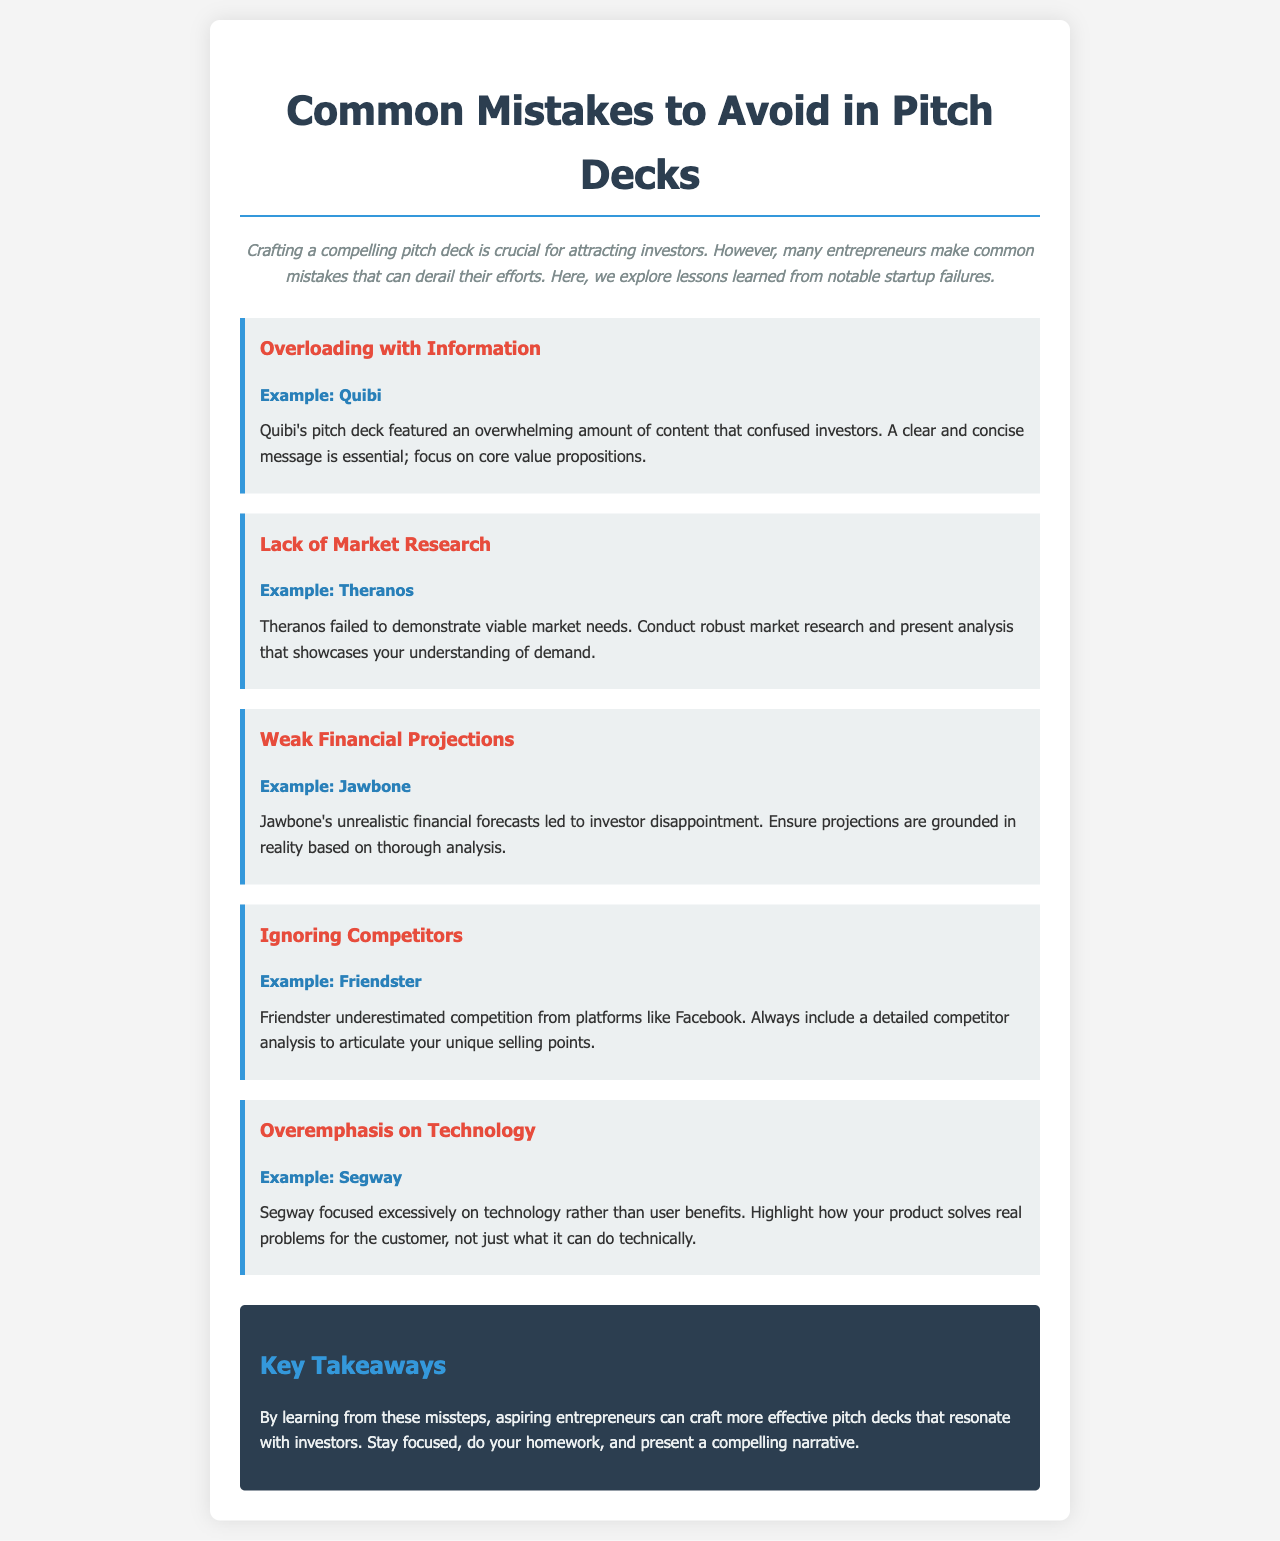what is the title of the document? The title of the document, which captures the main topic, is found at the top of the newsletter.
Answer: Common Mistakes to Avoid in Pitch Decks what example does the document provide for overloading with information? The document mentions a specific startup example to illustrate the mistake of overloading with information.
Answer: Quibi which startup is associated with a lack of market research? The document identifies a startup that failed due to insufficient market analysis.
Answer: Theranos what is highlighted as a common mistake in pitch decks? The document lists several mistakes; picking one mistake shows common pitfalls that entrepreneurs face.
Answer: Weak Financial Projections how many mistakes are discussed in the document? A count of the mistakes addressed throughout the newsletter reveals how many are presented.
Answer: Five what phrase encapsulates the key takeaways from the document? The conclusion summarizes the main learning points in a succinct phrase.
Answer: Key Takeaways which company is noted for overemphasizing technology? An example from the document points to a specific company that focused too much on technical aspects.
Answer: Segway what should entrepreneurs include in their pitch decks according to the document? The document recommends an essential element to include for effective pitches based on lessons learned.
Answer: Competitor analysis 